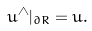Convert formula to latex. <formula><loc_0><loc_0><loc_500><loc_500>u ^ { \wedge } | _ { \partial R } = u .</formula> 